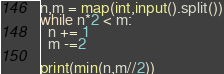Convert code to text. <code><loc_0><loc_0><loc_500><loc_500><_Python_>n,m = map(int,input().split())
while n*2 < m:
  n += 1
  m -=2

print(min(n,m//2))</code> 